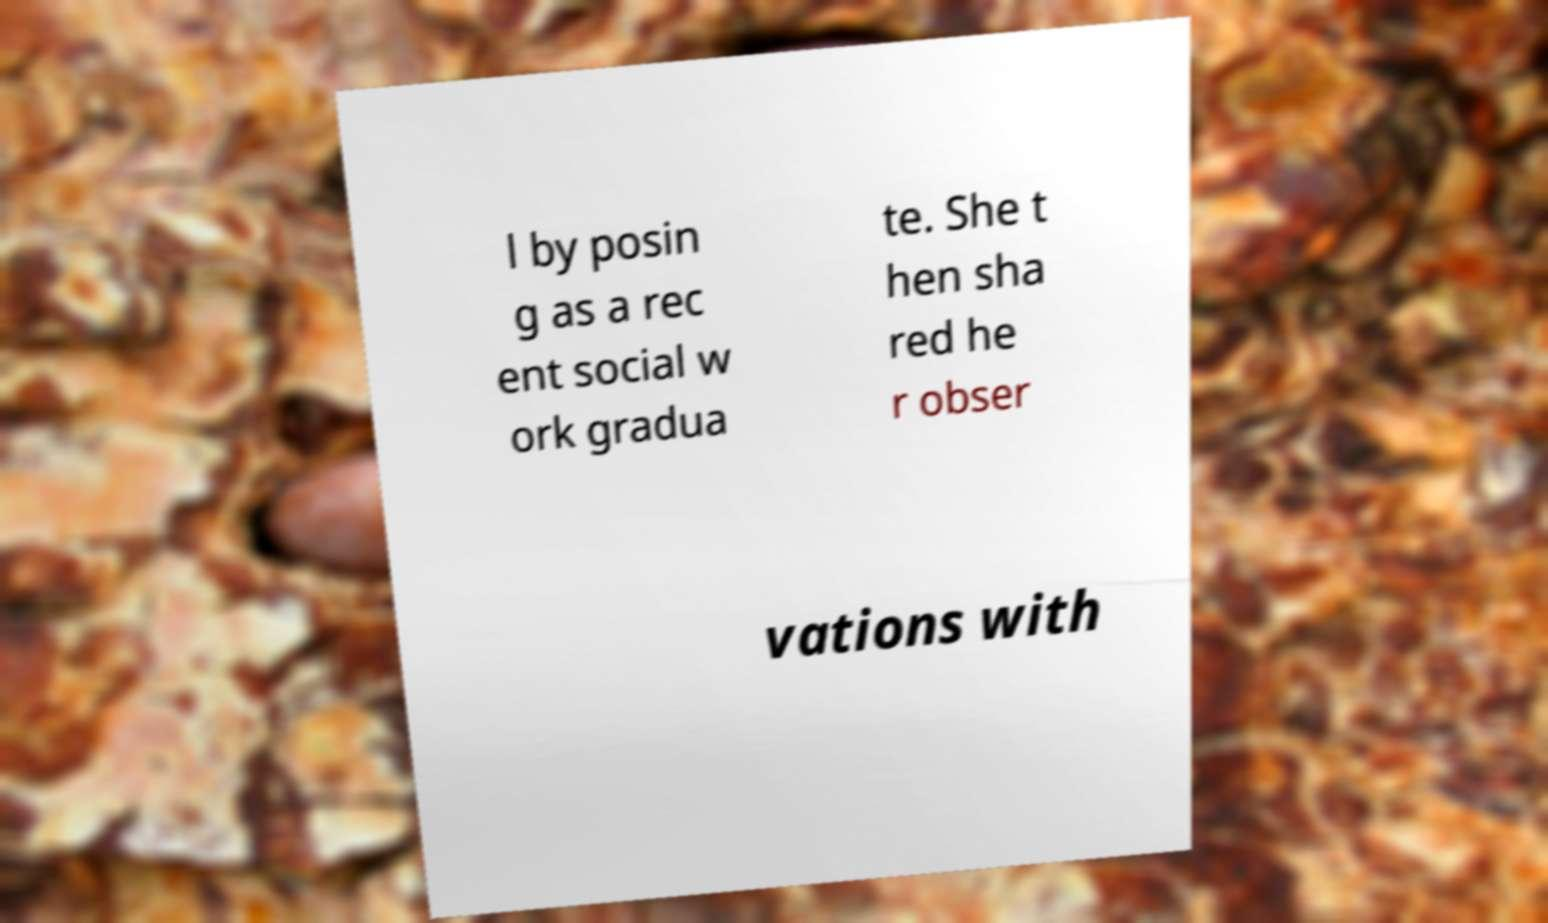For documentation purposes, I need the text within this image transcribed. Could you provide that? l by posin g as a rec ent social w ork gradua te. She t hen sha red he r obser vations with 